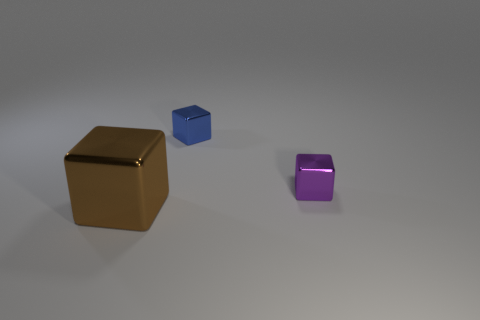There is a small metal cube left of the tiny object in front of the small thing that is behind the purple metallic object; what color is it?
Offer a very short reply. Blue. How many red things are either tiny metal blocks or big shiny objects?
Your response must be concise. 0. What number of small purple metal things have the same shape as the blue shiny thing?
Your answer should be very brief. 1. What is the shape of the other shiny thing that is the same size as the purple shiny thing?
Ensure brevity in your answer.  Cube. There is a big brown thing; are there any small objects left of it?
Your response must be concise. No. There is a tiny block to the right of the tiny blue block; is there a tiny cube behind it?
Give a very brief answer. Yes. Are there fewer big shiny things that are to the right of the brown metal object than small blue metallic blocks to the right of the tiny blue thing?
Provide a succinct answer. No. Are there any other things that have the same size as the brown metallic cube?
Your response must be concise. No. The purple object is what shape?
Give a very brief answer. Cube. There is a object that is behind the small purple metal object; what is its material?
Ensure brevity in your answer.  Metal. 